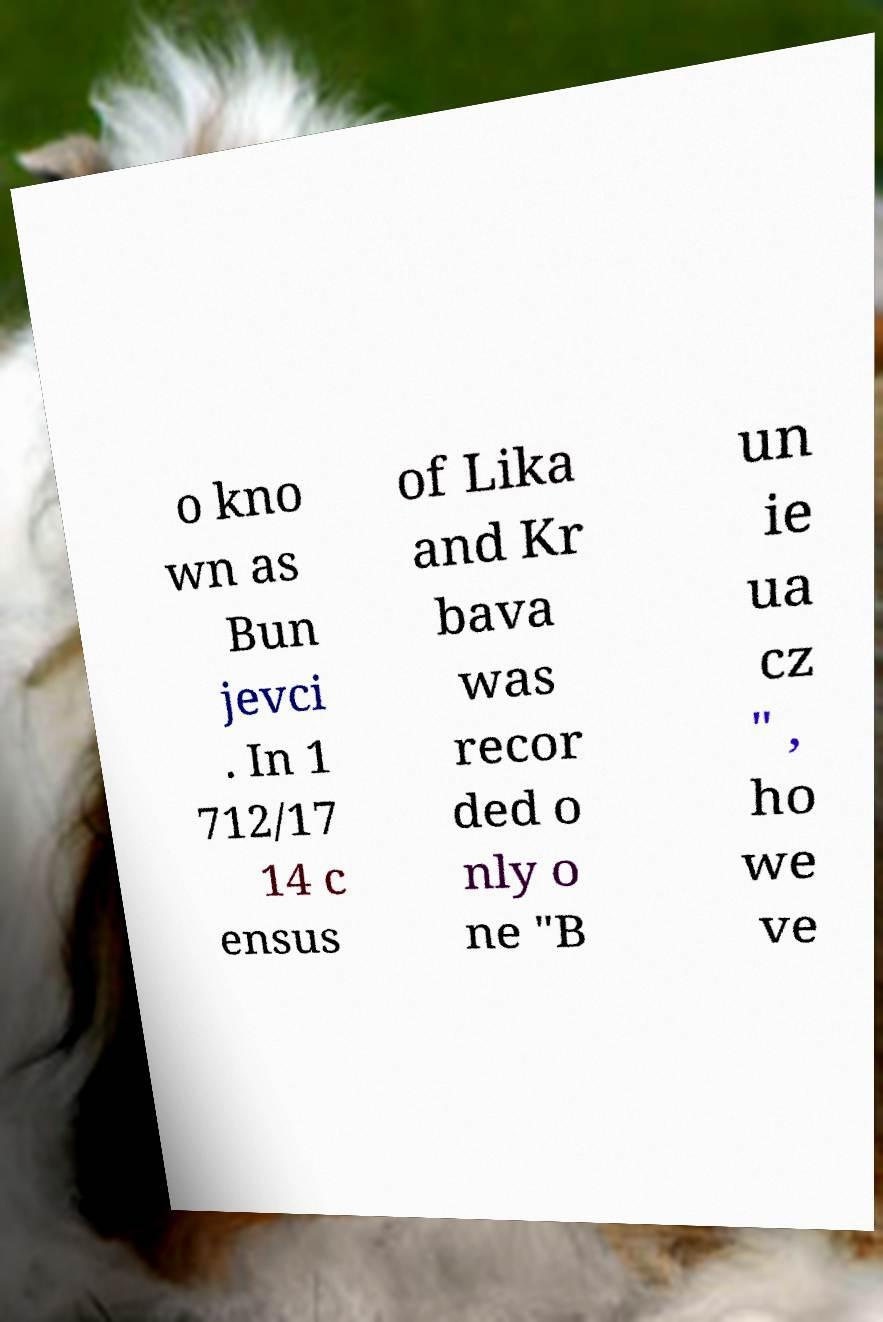I need the written content from this picture converted into text. Can you do that? o kno wn as Bun jevci . In 1 712/17 14 c ensus of Lika and Kr bava was recor ded o nly o ne "B un ie ua cz " , ho we ve 